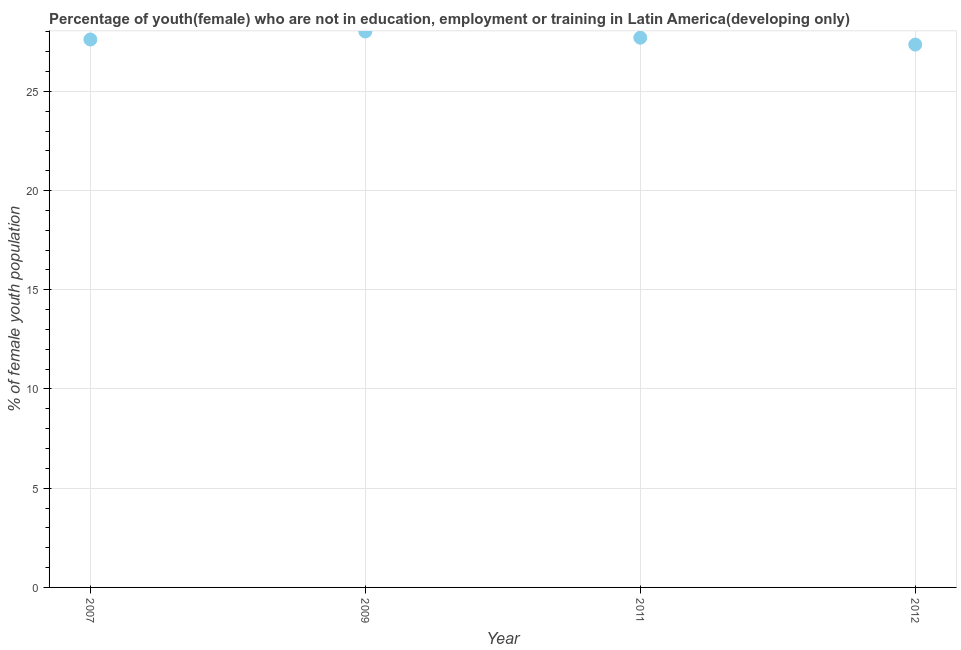What is the unemployed female youth population in 2012?
Give a very brief answer. 27.36. Across all years, what is the maximum unemployed female youth population?
Provide a succinct answer. 28.02. Across all years, what is the minimum unemployed female youth population?
Make the answer very short. 27.36. In which year was the unemployed female youth population maximum?
Keep it short and to the point. 2009. What is the sum of the unemployed female youth population?
Keep it short and to the point. 110.69. What is the difference between the unemployed female youth population in 2007 and 2012?
Ensure brevity in your answer.  0.25. What is the average unemployed female youth population per year?
Offer a very short reply. 27.67. What is the median unemployed female youth population?
Offer a terse response. 27.66. What is the ratio of the unemployed female youth population in 2009 to that in 2012?
Your response must be concise. 1.02. Is the unemployed female youth population in 2011 less than that in 2012?
Make the answer very short. No. Is the difference between the unemployed female youth population in 2007 and 2009 greater than the difference between any two years?
Your answer should be very brief. No. What is the difference between the highest and the second highest unemployed female youth population?
Your answer should be very brief. 0.31. Is the sum of the unemployed female youth population in 2009 and 2012 greater than the maximum unemployed female youth population across all years?
Your answer should be very brief. Yes. What is the difference between the highest and the lowest unemployed female youth population?
Provide a succinct answer. 0.66. Does the unemployed female youth population monotonically increase over the years?
Ensure brevity in your answer.  No. How many dotlines are there?
Make the answer very short. 1. Does the graph contain grids?
Your answer should be very brief. Yes. What is the title of the graph?
Provide a short and direct response. Percentage of youth(female) who are not in education, employment or training in Latin America(developing only). What is the label or title of the X-axis?
Give a very brief answer. Year. What is the label or title of the Y-axis?
Your answer should be compact. % of female youth population. What is the % of female youth population in 2007?
Offer a terse response. 27.61. What is the % of female youth population in 2009?
Your response must be concise. 28.02. What is the % of female youth population in 2011?
Give a very brief answer. 27.7. What is the % of female youth population in 2012?
Keep it short and to the point. 27.36. What is the difference between the % of female youth population in 2007 and 2009?
Your answer should be compact. -0.4. What is the difference between the % of female youth population in 2007 and 2011?
Make the answer very short. -0.09. What is the difference between the % of female youth population in 2007 and 2012?
Your response must be concise. 0.25. What is the difference between the % of female youth population in 2009 and 2011?
Your answer should be compact. 0.31. What is the difference between the % of female youth population in 2009 and 2012?
Provide a succinct answer. 0.66. What is the difference between the % of female youth population in 2011 and 2012?
Your answer should be compact. 0.35. What is the ratio of the % of female youth population in 2007 to that in 2009?
Provide a short and direct response. 0.99. What is the ratio of the % of female youth population in 2007 to that in 2011?
Your answer should be compact. 1. What is the ratio of the % of female youth population in 2007 to that in 2012?
Provide a succinct answer. 1.01. What is the ratio of the % of female youth population in 2009 to that in 2011?
Keep it short and to the point. 1.01. 